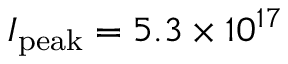<formula> <loc_0><loc_0><loc_500><loc_500>I _ { p e a k } = 5 . 3 \times 1 0 ^ { 1 7 }</formula> 